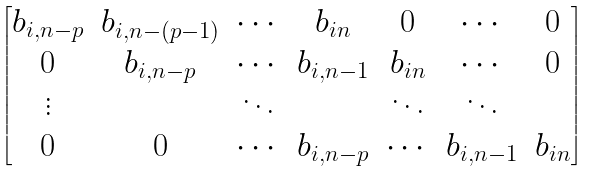Convert formula to latex. <formula><loc_0><loc_0><loc_500><loc_500>\begin{bmatrix} b _ { i , n - p } & b _ { i , n - ( p - 1 ) } & \cdots & b _ { i n } & 0 & \cdots & 0 \\ 0 & b _ { i , n - p } & \cdots & b _ { i , n - 1 } & b _ { i n } & \cdots & 0 \\ \vdots & & \ddots & & \ddots & \ddots & \\ 0 & 0 & \cdots & b _ { i , n - p } & \cdots & b _ { i , n - 1 } & b _ { i n } \end{bmatrix}</formula> 